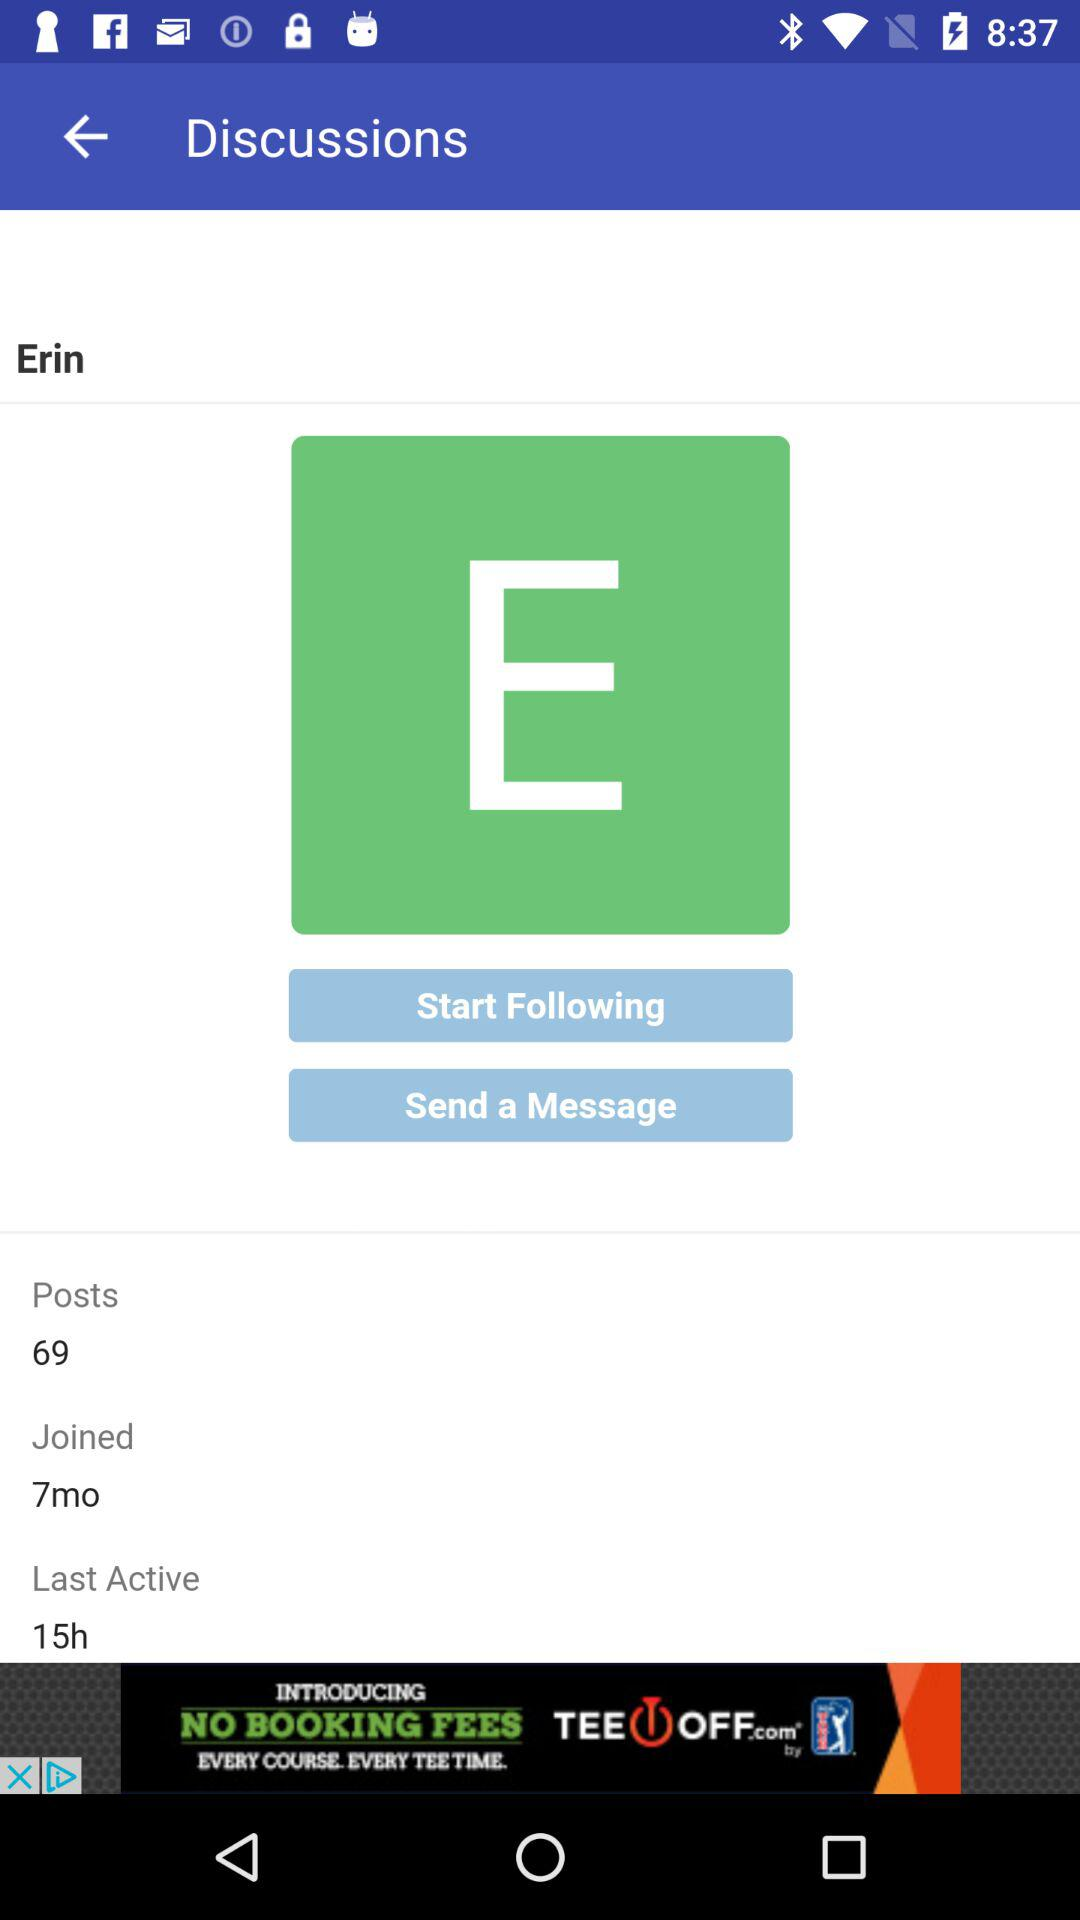When was the user last active? The user was last active 15 hours ago. 